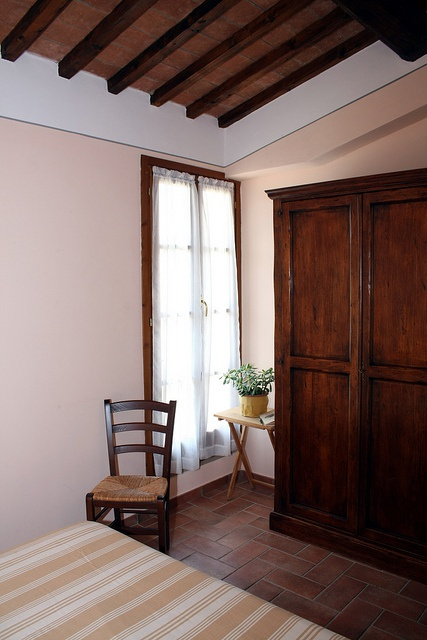Describe the objects in this image and their specific colors. I can see bed in maroon, darkgray, tan, and gray tones, chair in maroon, black, darkgray, and gray tones, and potted plant in maroon, lightgray, darkgray, black, and gray tones in this image. 